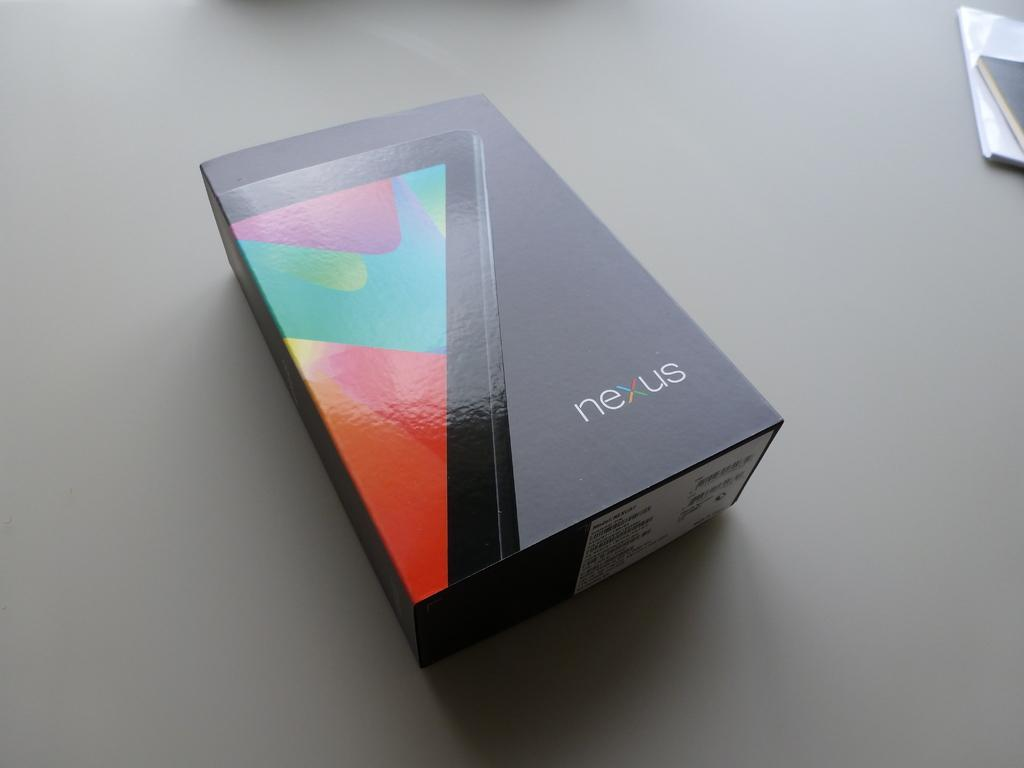<image>
Share a concise interpretation of the image provided. A closed box sitting on a table with the word nexus. 